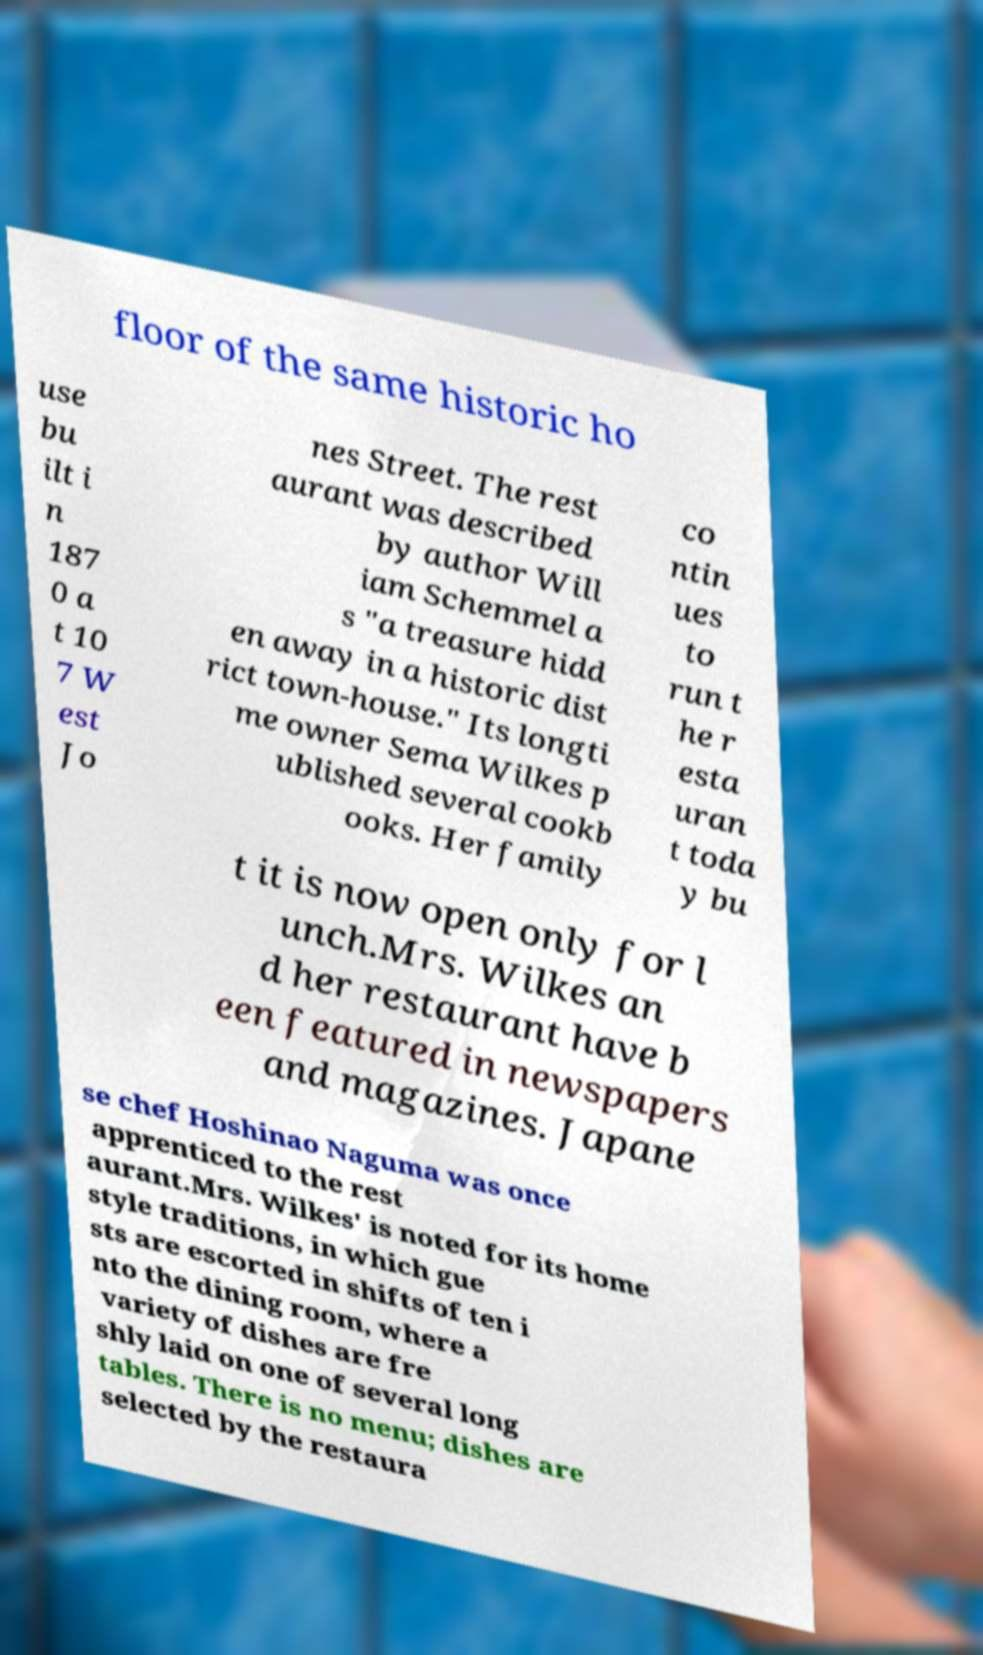I need the written content from this picture converted into text. Can you do that? floor of the same historic ho use bu ilt i n 187 0 a t 10 7 W est Jo nes Street. The rest aurant was described by author Will iam Schemmel a s "a treasure hidd en away in a historic dist rict town-house." Its longti me owner Sema Wilkes p ublished several cookb ooks. Her family co ntin ues to run t he r esta uran t toda y bu t it is now open only for l unch.Mrs. Wilkes an d her restaurant have b een featured in newspapers and magazines. Japane se chef Hoshinao Naguma was once apprenticed to the rest aurant.Mrs. Wilkes' is noted for its home style traditions, in which gue sts are escorted in shifts of ten i nto the dining room, where a variety of dishes are fre shly laid on one of several long tables. There is no menu; dishes are selected by the restaura 